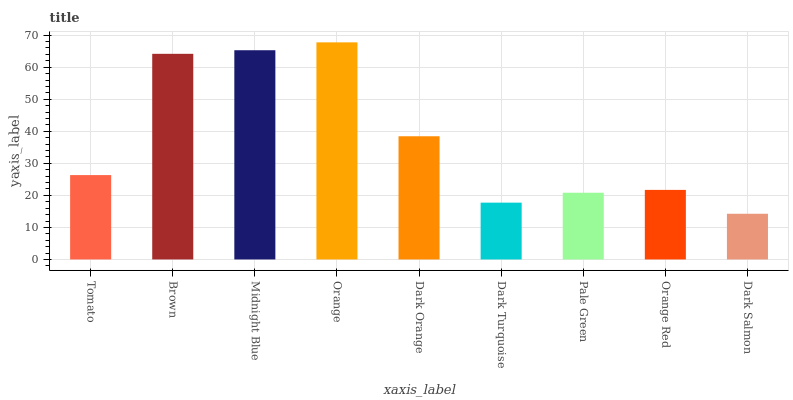Is Dark Salmon the minimum?
Answer yes or no. Yes. Is Orange the maximum?
Answer yes or no. Yes. Is Brown the minimum?
Answer yes or no. No. Is Brown the maximum?
Answer yes or no. No. Is Brown greater than Tomato?
Answer yes or no. Yes. Is Tomato less than Brown?
Answer yes or no. Yes. Is Tomato greater than Brown?
Answer yes or no. No. Is Brown less than Tomato?
Answer yes or no. No. Is Tomato the high median?
Answer yes or no. Yes. Is Tomato the low median?
Answer yes or no. Yes. Is Dark Salmon the high median?
Answer yes or no. No. Is Midnight Blue the low median?
Answer yes or no. No. 